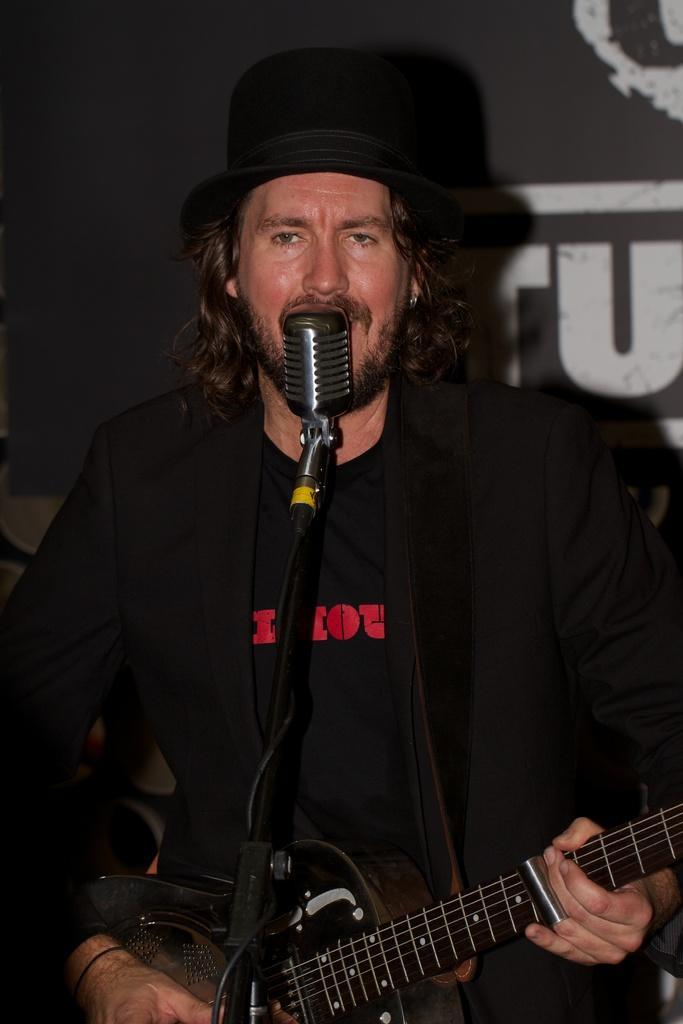How would you summarize this image in a sentence or two? In this image i can see a person wearing a hat, holding a guitar and i can see a microphone in front of him. 